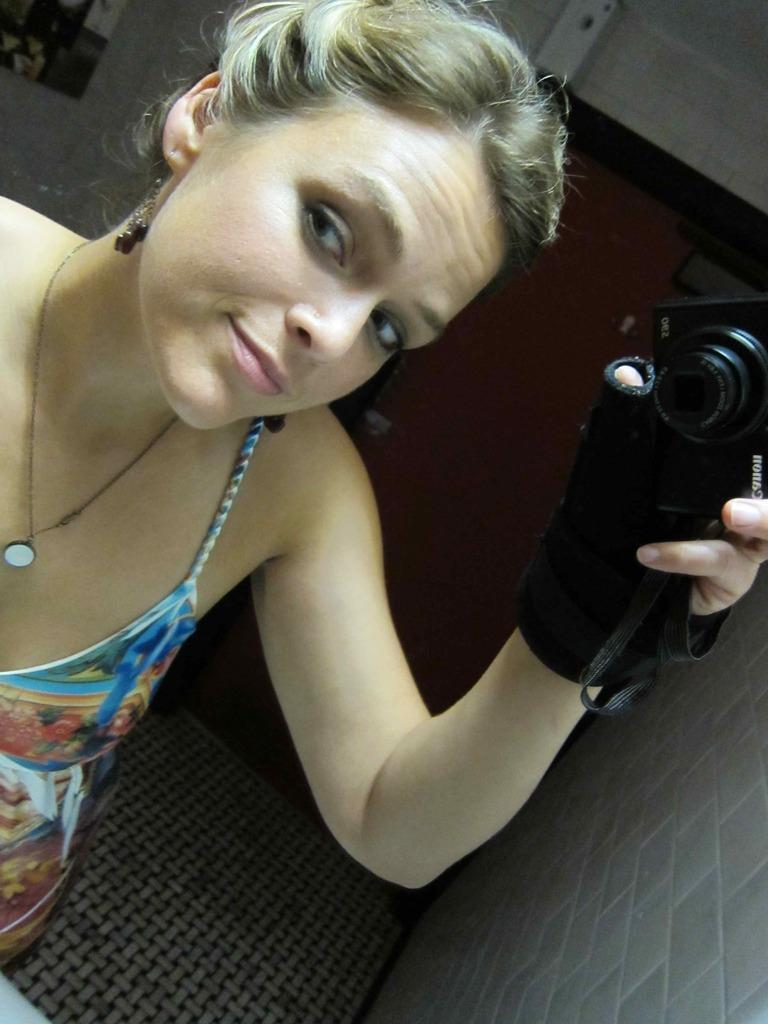What is the main subject of the image? There is a person in the image. What is the person holding in her hand? The person is holding a camera in her hand. What type of clothing is the person wearing on her hand? The person is wearing a black glove. What can be seen on the right side of the image? There is a wall on the right side of the image. What is the person wearing as her main outfit? The person is wearing a blue and white dress. What type of butter is being used by the person in the image? There is no butter present in the image. How many bits of information can be gathered from the image? The number of bits of information cannot be determined from the image, as it is not a digital file. 